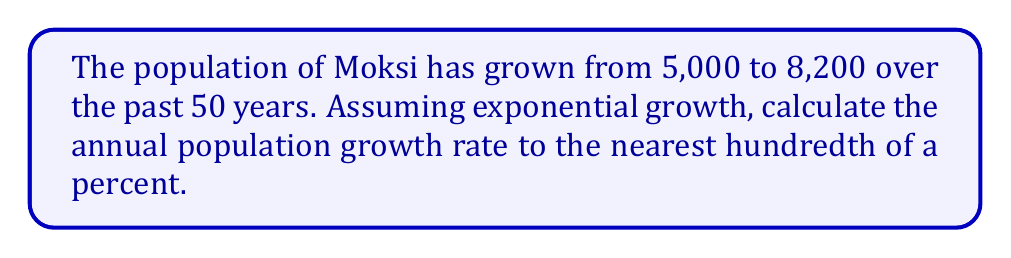Help me with this question. Let's approach this step-by-step:

1) The exponential growth formula is:
   $A = P(1 + r)^t$
   Where:
   $A$ is the final amount (8,200)
   $P$ is the initial amount (5,000)
   $r$ is the annual growth rate (what we're solving for)
   $t$ is the time in years (50)

2) Plugging in our known values:
   $8200 = 5000(1 + r)^{50}$

3) Divide both sides by 5000:
   $\frac{8200}{5000} = (1 + r)^{50}$

4) Simplify:
   $1.64 = (1 + r)^{50}$

5) Take the 50th root of both sides:
   $\sqrt[50]{1.64} = 1 + r$

6) Subtract 1 from both sides:
   $\sqrt[50]{1.64} - 1 = r$

7) Calculate:
   $r \approx 0.0099$

8) Convert to a percentage:
   $r \approx 0.99\%$

Therefore, the annual population growth rate is approximately 0.99%.
Answer: 0.99% 